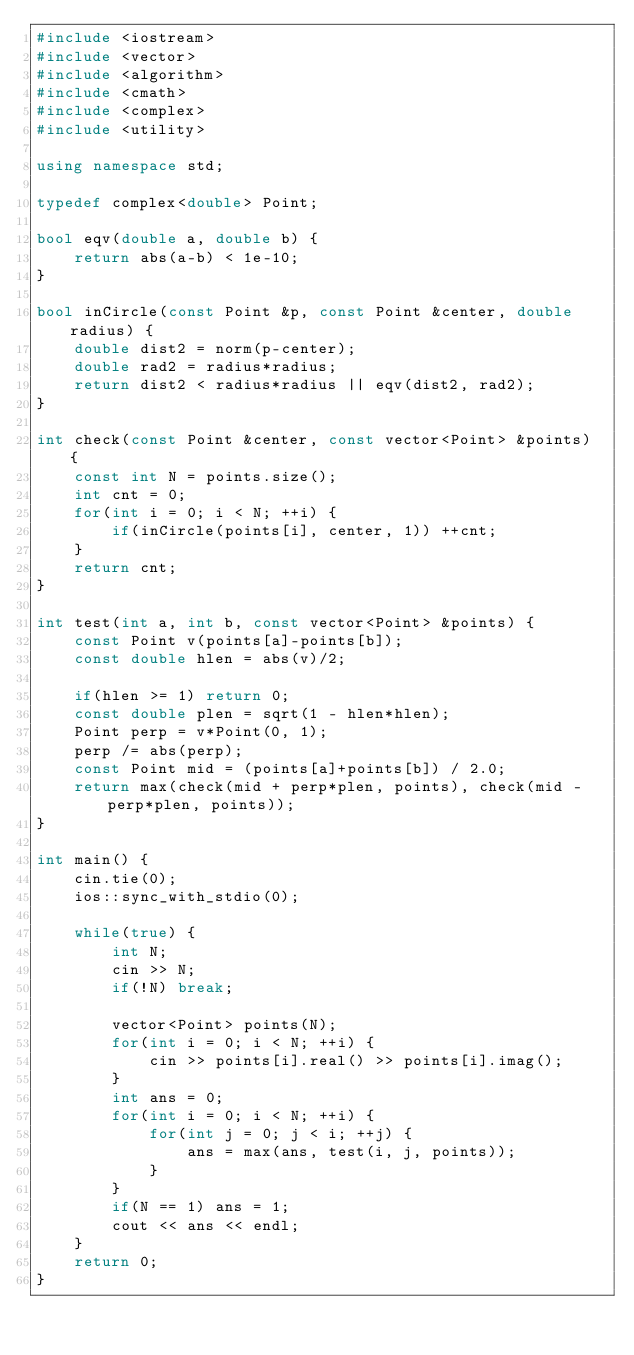<code> <loc_0><loc_0><loc_500><loc_500><_C++_>#include <iostream>
#include <vector>
#include <algorithm>
#include <cmath>
#include <complex>
#include <utility>

using namespace std;

typedef complex<double> Point;

bool eqv(double a, double b) {
    return abs(a-b) < 1e-10;
}

bool inCircle(const Point &p, const Point &center, double radius) {
    double dist2 = norm(p-center);
    double rad2 = radius*radius;
    return dist2 < radius*radius || eqv(dist2, rad2);
}

int check(const Point &center, const vector<Point> &points) {
    const int N = points.size();
    int cnt = 0;
    for(int i = 0; i < N; ++i) {
        if(inCircle(points[i], center, 1)) ++cnt;
    }
    return cnt;
}

int test(int a, int b, const vector<Point> &points) {
    const Point v(points[a]-points[b]);
    const double hlen = abs(v)/2;

    if(hlen >= 1) return 0;
    const double plen = sqrt(1 - hlen*hlen);
    Point perp = v*Point(0, 1);
    perp /= abs(perp);
    const Point mid = (points[a]+points[b]) / 2.0;
    return max(check(mid + perp*plen, points), check(mid - perp*plen, points));
}

int main() {
    cin.tie(0);
    ios::sync_with_stdio(0);

    while(true) {
        int N;
        cin >> N;
        if(!N) break;

        vector<Point> points(N);
        for(int i = 0; i < N; ++i) {
            cin >> points[i].real() >> points[i].imag();
        }
        int ans = 0;
        for(int i = 0; i < N; ++i) {
            for(int j = 0; j < i; ++j) {
                ans = max(ans, test(i, j, points));
            }
        }
        if(N == 1) ans = 1;
        cout << ans << endl;
    }
    return 0;
}</code> 